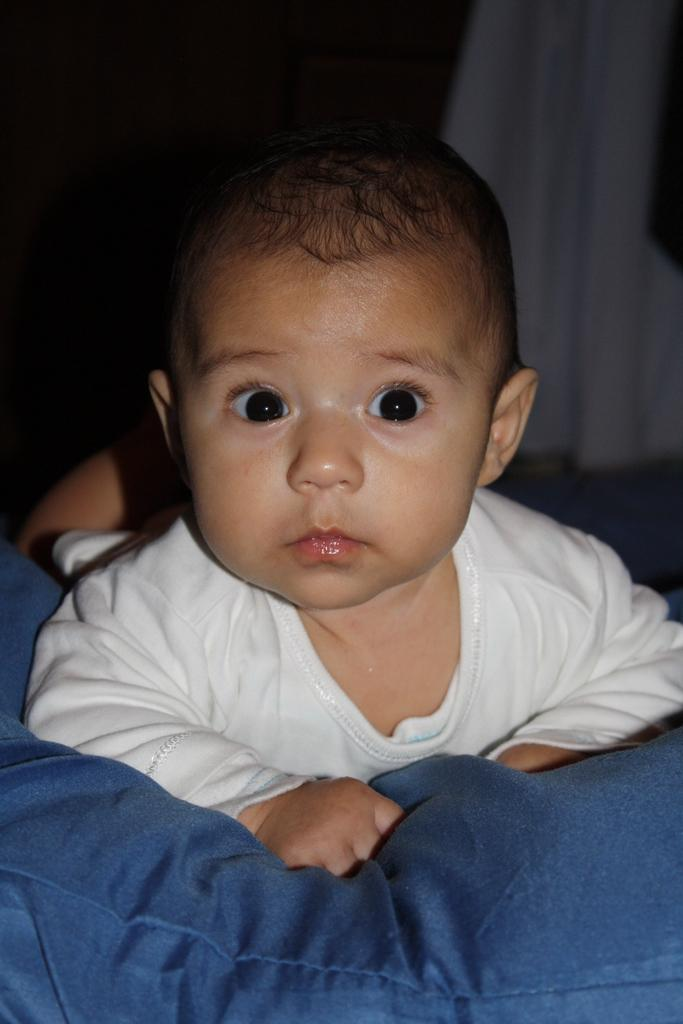What is the main subject of the image? The main subject of the image is a baby. Where is the baby located in the image? The baby is on a bed. What is the color of the background in the image? The background of the image is dark. What type of grain is being harvested by the queen in the image? There is no queen or grain present in the image; it features a baby on a bed with a dark background. What type of iron is visible in the image? There is no iron present in the image. 